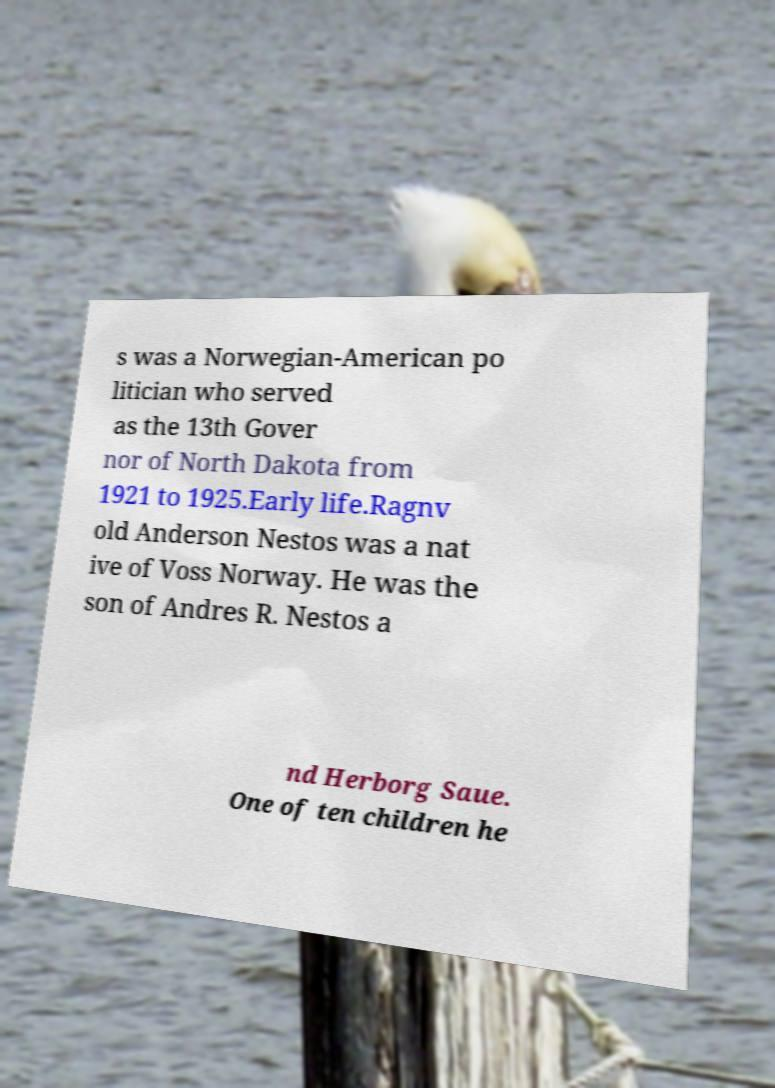I need the written content from this picture converted into text. Can you do that? s was a Norwegian-American po litician who served as the 13th Gover nor of North Dakota from 1921 to 1925.Early life.Ragnv old Anderson Nestos was a nat ive of Voss Norway. He was the son of Andres R. Nestos a nd Herborg Saue. One of ten children he 